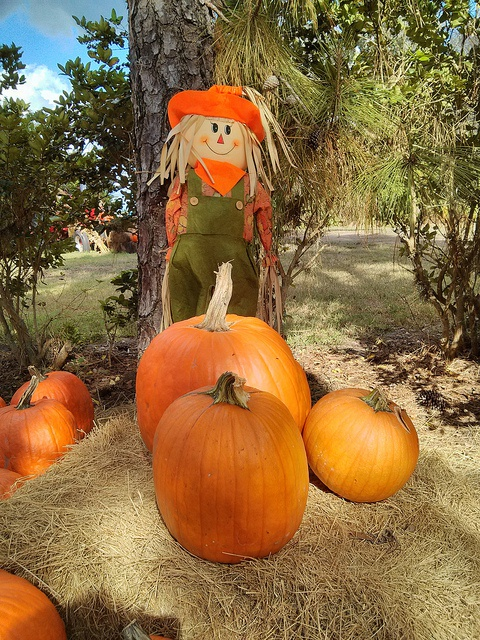Describe the objects in this image and their specific colors. I can see various objects in this image with different colors. 